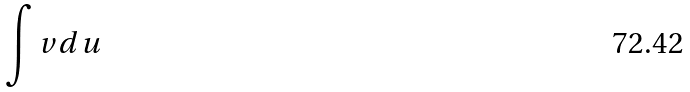Convert formula to latex. <formula><loc_0><loc_0><loc_500><loc_500>\int v d u</formula> 